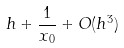Convert formula to latex. <formula><loc_0><loc_0><loc_500><loc_500>h + \frac { 1 } { x _ { 0 } } + O ( h ^ { 3 } )</formula> 